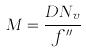<formula> <loc_0><loc_0><loc_500><loc_500>M = \frac { D N _ { v } } { f ^ { \prime \prime } }</formula> 